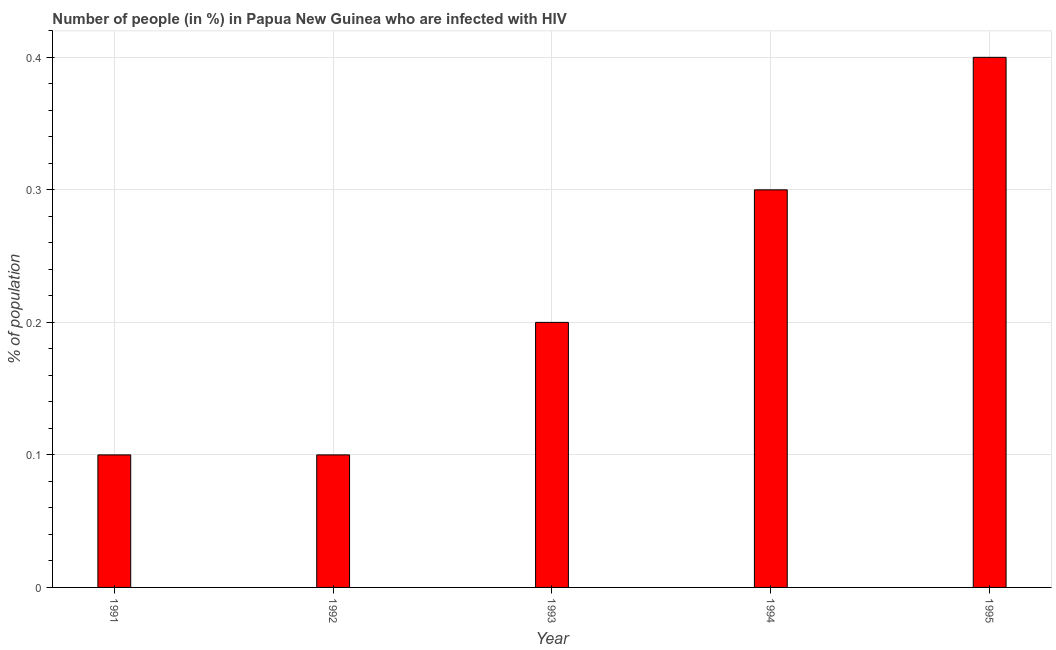Does the graph contain any zero values?
Give a very brief answer. No. What is the title of the graph?
Keep it short and to the point. Number of people (in %) in Papua New Guinea who are infected with HIV. What is the label or title of the X-axis?
Offer a very short reply. Year. What is the label or title of the Y-axis?
Keep it short and to the point. % of population. What is the number of people infected with hiv in 1995?
Give a very brief answer. 0.4. Across all years, what is the maximum number of people infected with hiv?
Provide a short and direct response. 0.4. Across all years, what is the minimum number of people infected with hiv?
Offer a very short reply. 0.1. In which year was the number of people infected with hiv minimum?
Your answer should be compact. 1991. What is the sum of the number of people infected with hiv?
Provide a short and direct response. 1.1. What is the difference between the number of people infected with hiv in 1992 and 1994?
Provide a short and direct response. -0.2. What is the average number of people infected with hiv per year?
Keep it short and to the point. 0.22. What is the median number of people infected with hiv?
Your answer should be compact. 0.2. In how many years, is the number of people infected with hiv greater than 0.24 %?
Your response must be concise. 2. What is the ratio of the number of people infected with hiv in 1991 to that in 1995?
Make the answer very short. 0.25. What is the difference between the highest and the second highest number of people infected with hiv?
Provide a succinct answer. 0.1. Are all the bars in the graph horizontal?
Your answer should be very brief. No. What is the % of population of 1991?
Your answer should be very brief. 0.1. What is the % of population in 1995?
Your response must be concise. 0.4. What is the difference between the % of population in 1991 and 1992?
Offer a terse response. 0. What is the difference between the % of population in 1991 and 1995?
Your answer should be very brief. -0.3. What is the difference between the % of population in 1992 and 1993?
Your answer should be compact. -0.1. What is the difference between the % of population in 1992 and 1994?
Provide a succinct answer. -0.2. What is the difference between the % of population in 1993 and 1994?
Provide a short and direct response. -0.1. What is the difference between the % of population in 1994 and 1995?
Ensure brevity in your answer.  -0.1. What is the ratio of the % of population in 1991 to that in 1993?
Offer a terse response. 0.5. What is the ratio of the % of population in 1991 to that in 1994?
Provide a succinct answer. 0.33. What is the ratio of the % of population in 1992 to that in 1993?
Your answer should be compact. 0.5. What is the ratio of the % of population in 1992 to that in 1994?
Offer a very short reply. 0.33. What is the ratio of the % of population in 1992 to that in 1995?
Provide a short and direct response. 0.25. What is the ratio of the % of population in 1993 to that in 1994?
Your answer should be compact. 0.67. What is the ratio of the % of population in 1993 to that in 1995?
Provide a short and direct response. 0.5. 